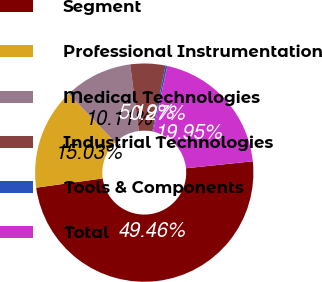<chart> <loc_0><loc_0><loc_500><loc_500><pie_chart><fcel>Segment<fcel>Professional Instrumentation<fcel>Medical Technologies<fcel>Industrial Technologies<fcel>Tools & Components<fcel>Total<nl><fcel>49.46%<fcel>15.03%<fcel>10.11%<fcel>5.19%<fcel>0.27%<fcel>19.95%<nl></chart> 